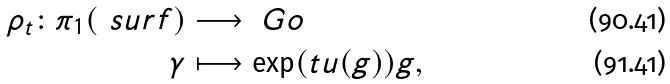Convert formula to latex. <formula><loc_0><loc_0><loc_500><loc_500>\rho _ { t } \colon \pi _ { 1 } ( \ s u r f ) & \longrightarrow \ G o \\ \gamma & \longmapsto \exp ( t u ( g ) ) g ,</formula> 